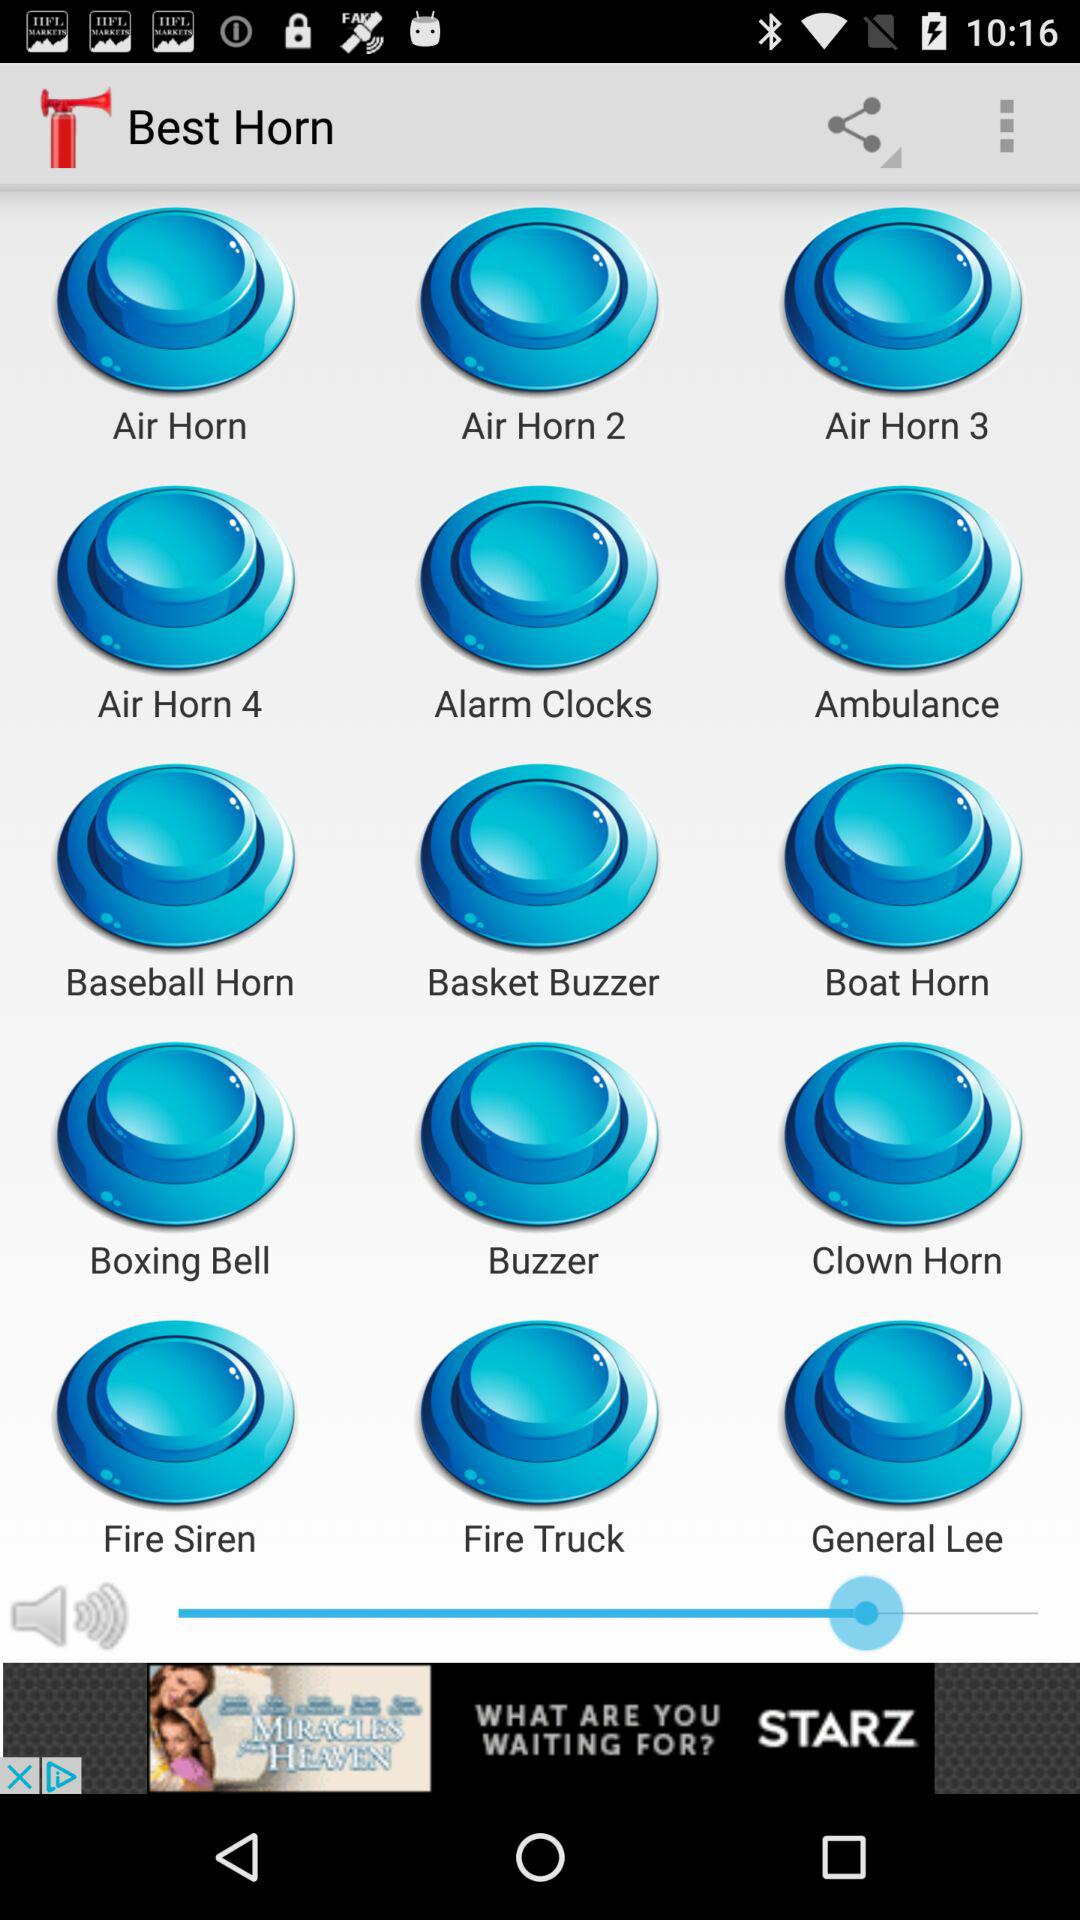How many more air horns are there than ambulance sounds?
Answer the question using a single word or phrase. 3 